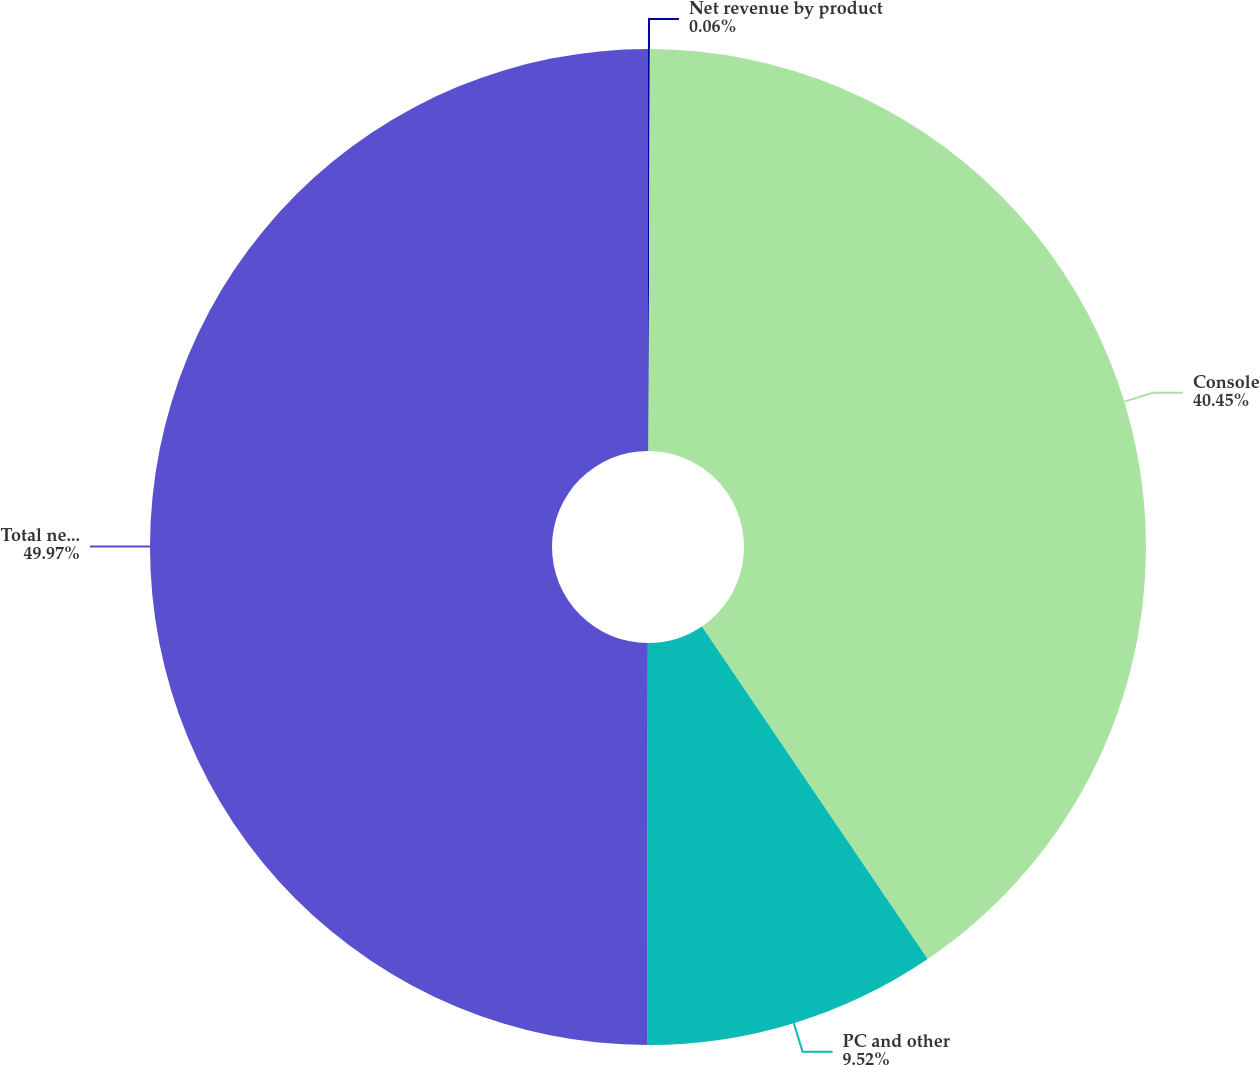<chart> <loc_0><loc_0><loc_500><loc_500><pie_chart><fcel>Net revenue by product<fcel>Console<fcel>PC and other<fcel>Total net revenue<nl><fcel>0.06%<fcel>40.45%<fcel>9.52%<fcel>49.97%<nl></chart> 